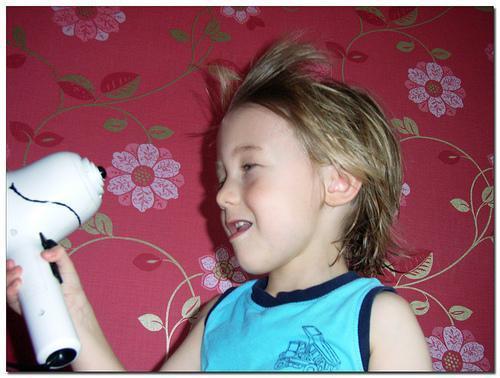How many kids are eating ice cream?
Give a very brief answer. 0. 